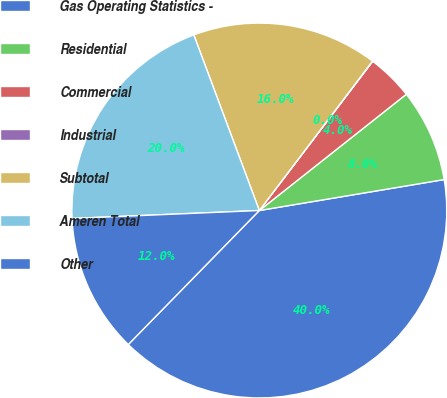Convert chart. <chart><loc_0><loc_0><loc_500><loc_500><pie_chart><fcel>Gas Operating Statistics -<fcel>Residential<fcel>Commercial<fcel>Industrial<fcel>Subtotal<fcel>Ameren Total<fcel>Other<nl><fcel>39.96%<fcel>8.01%<fcel>4.01%<fcel>0.02%<fcel>16.0%<fcel>19.99%<fcel>12.0%<nl></chart> 